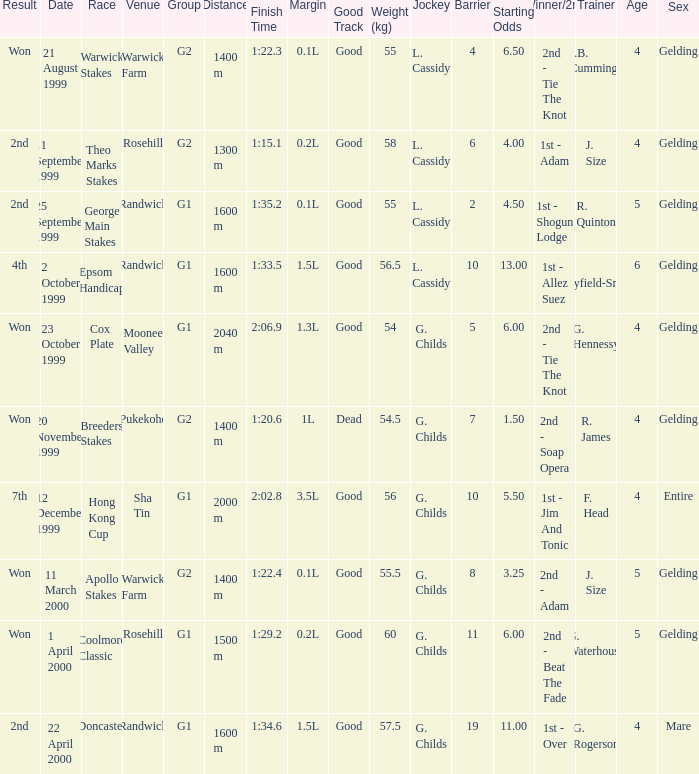What is the number of teams with a total weight of 57.5? 1.0. 